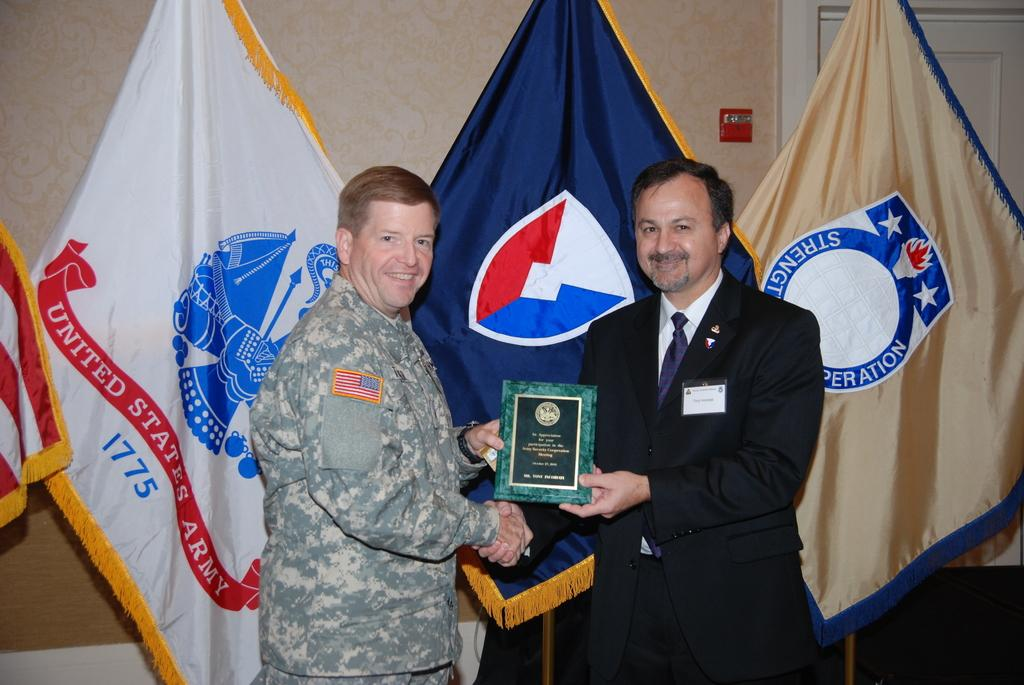<image>
Describe the image concisely. A man in a suit handing a man in a army uniform a plaque as the United States Army 1775 flag is behind 